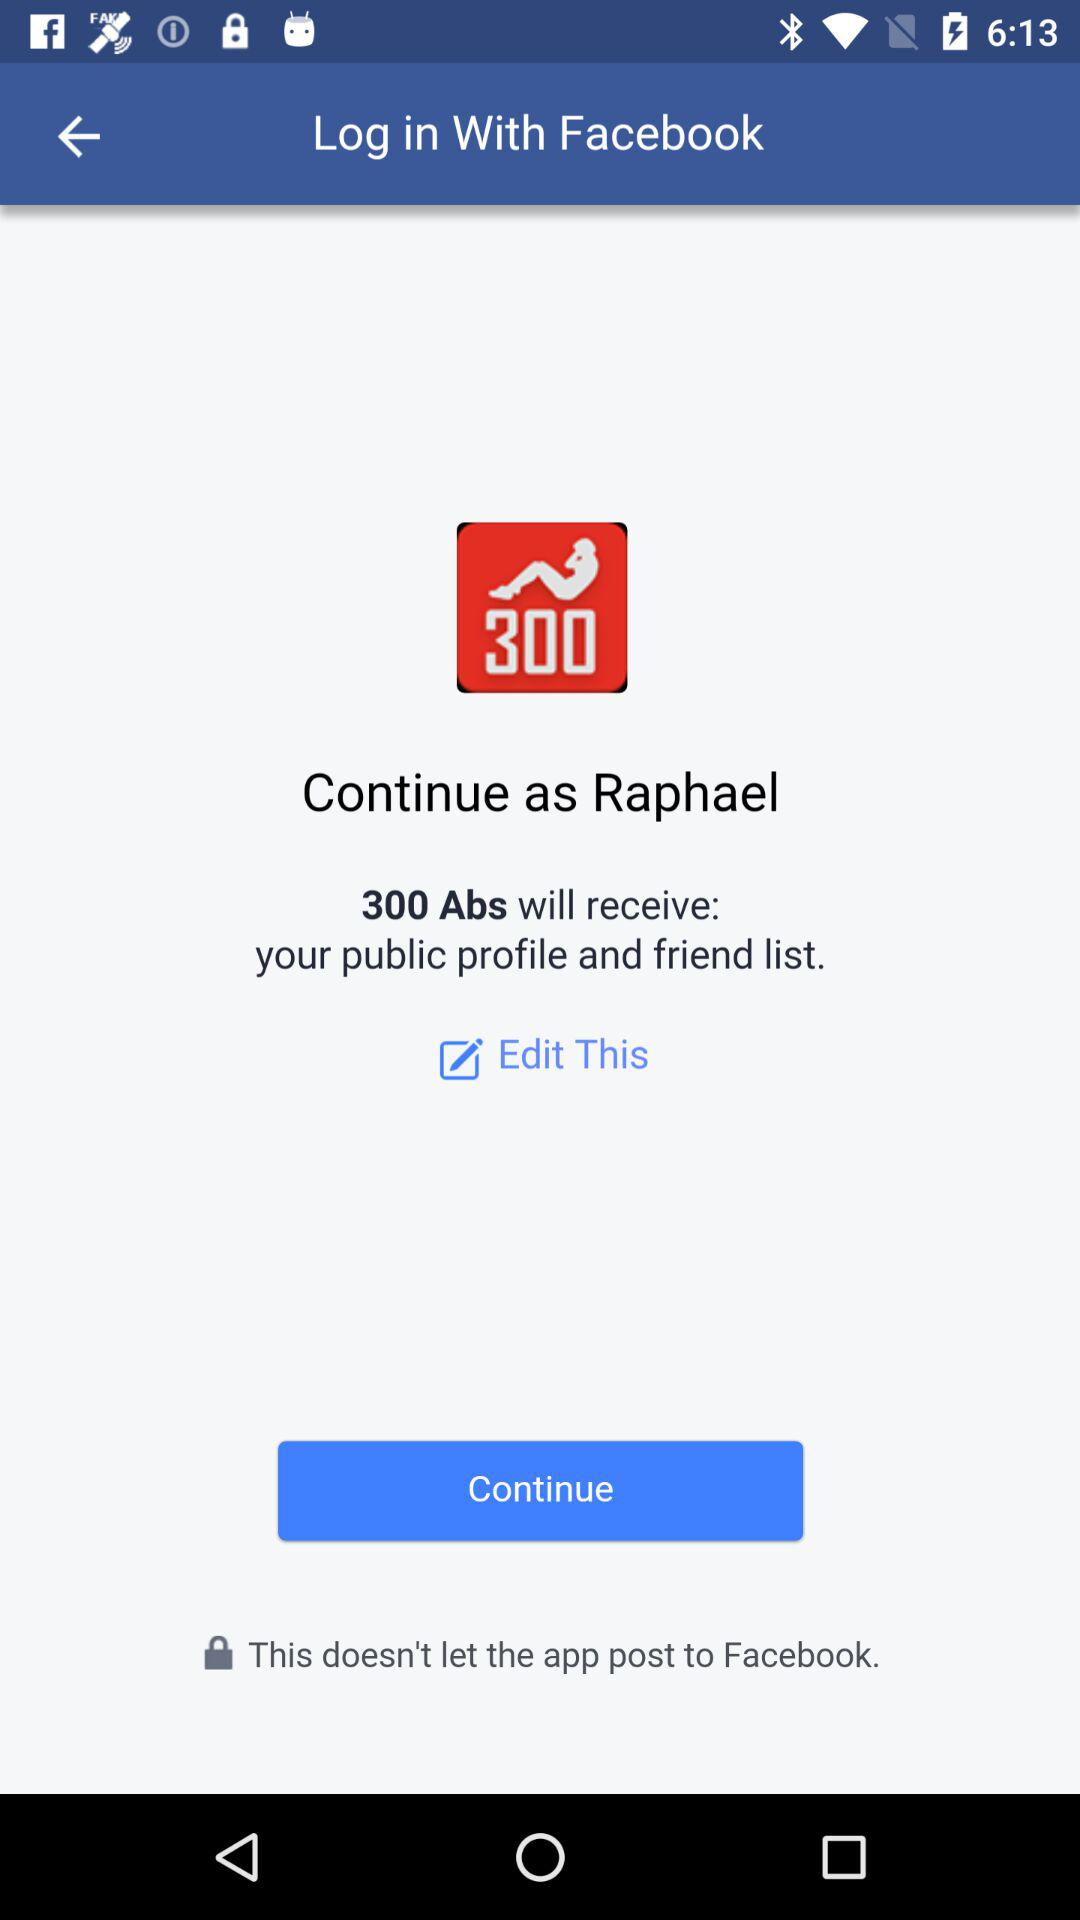What application is asking for permission? The application asking for permission is "300 Abs". 